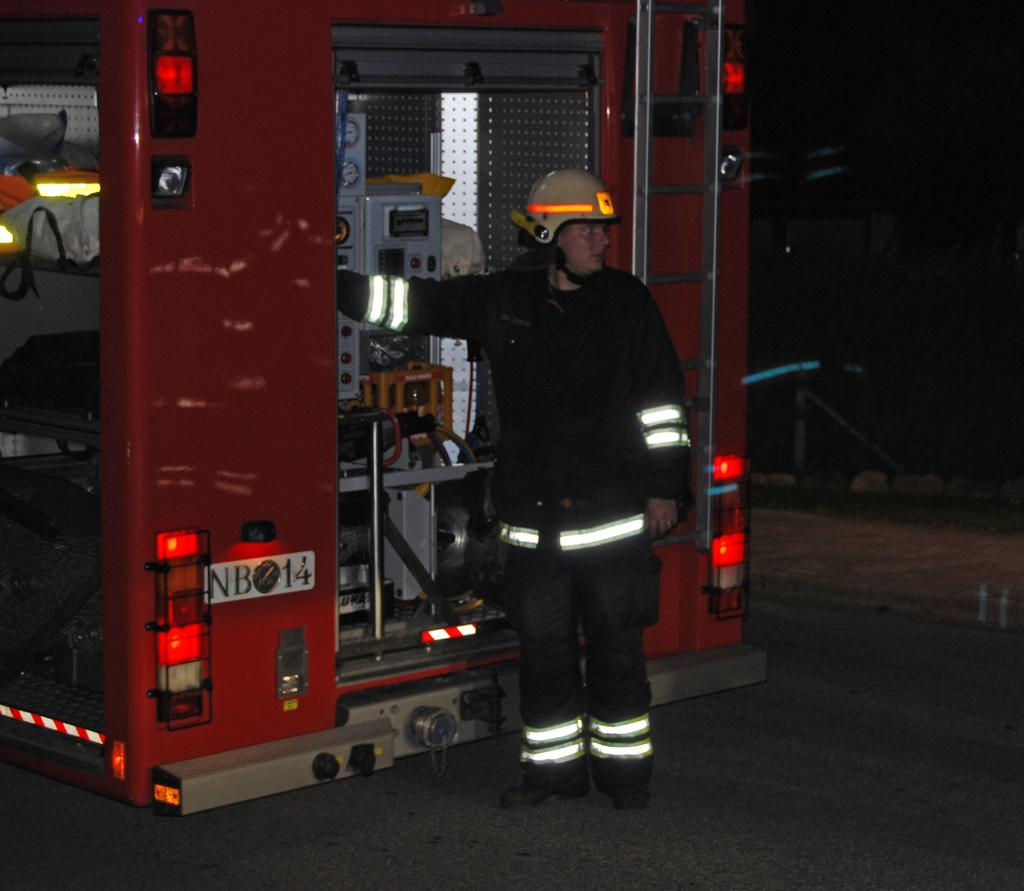Who is present in the image? There is a person in the image. What is the person wearing on their head? The person is wearing a helmet. What type of vehicle is near the person? The person is standing near a fire engine vehicle. What type of mint is growing near the fire engine vehicle? There is no mint present in the image; it only features a person wearing a helmet and standing near a fire engine vehicle. 